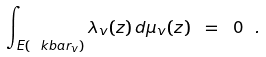Convert formula to latex. <formula><loc_0><loc_0><loc_500><loc_500>\int _ { E ( \ k b a r _ { v } ) } \lambda _ { v } ( z ) \, d \mu _ { v } ( z ) \ = \ 0 \ .</formula> 